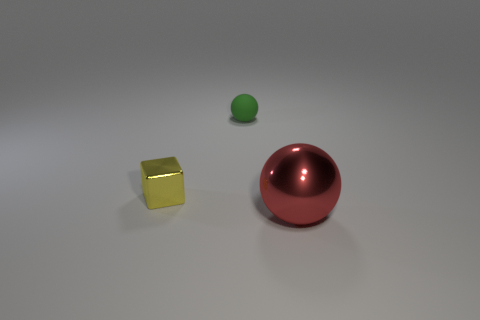There is a shiny object behind the sphere that is in front of the small green matte ball; is there a cube in front of it?
Provide a short and direct response. No. How many shiny objects are either big red objects or tiny yellow blocks?
Your answer should be compact. 2. Does the metal block have the same color as the tiny matte ball?
Offer a very short reply. No. How many blocks are to the left of the yellow metal object?
Offer a very short reply. 0. What number of small objects are both behind the small metallic block and on the left side of the green matte object?
Provide a short and direct response. 0. There is a red thing that is the same material as the cube; what is its shape?
Your answer should be very brief. Sphere. There is a ball that is left of the big shiny thing; is it the same size as the metal object left of the big metallic ball?
Provide a short and direct response. Yes. What is the color of the ball behind the large red shiny ball?
Keep it short and to the point. Green. What material is the object on the right side of the sphere behind the red metal thing?
Your answer should be compact. Metal. What is the shape of the small green matte object?
Your response must be concise. Sphere. 